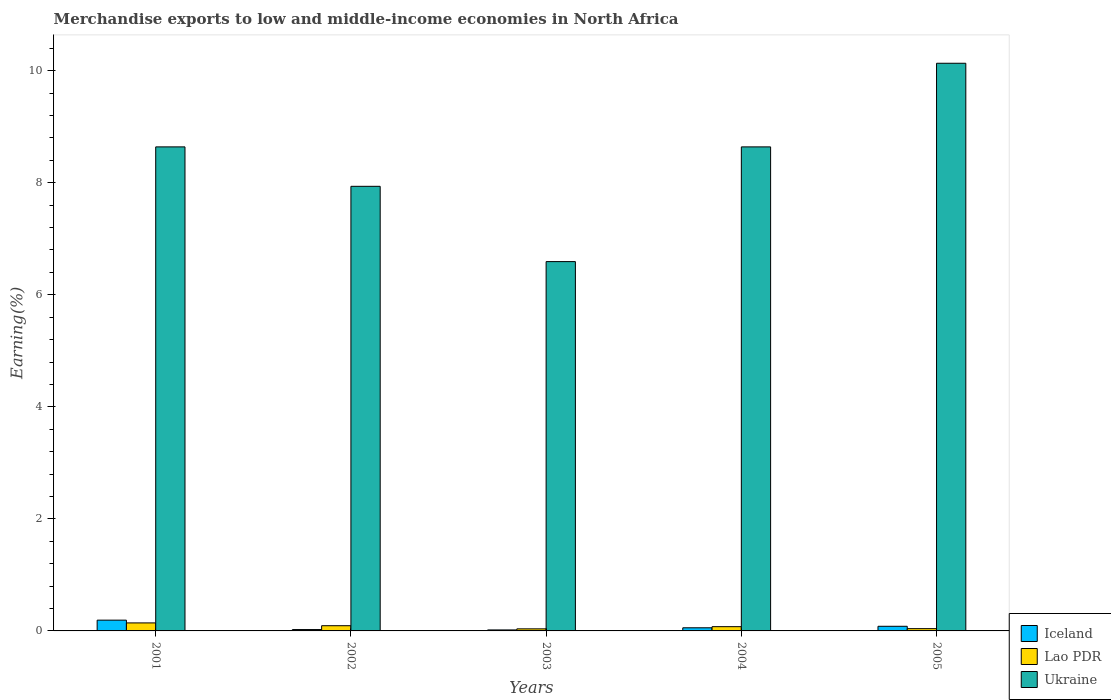How many different coloured bars are there?
Ensure brevity in your answer.  3. How many bars are there on the 3rd tick from the left?
Give a very brief answer. 3. What is the percentage of amount earned from merchandise exports in Lao PDR in 2002?
Give a very brief answer. 0.09. Across all years, what is the maximum percentage of amount earned from merchandise exports in Iceland?
Your response must be concise. 0.19. Across all years, what is the minimum percentage of amount earned from merchandise exports in Lao PDR?
Ensure brevity in your answer.  0.04. In which year was the percentage of amount earned from merchandise exports in Iceland maximum?
Ensure brevity in your answer.  2001. What is the total percentage of amount earned from merchandise exports in Ukraine in the graph?
Ensure brevity in your answer.  41.94. What is the difference between the percentage of amount earned from merchandise exports in Ukraine in 2002 and that in 2005?
Offer a terse response. -2.2. What is the difference between the percentage of amount earned from merchandise exports in Iceland in 2001 and the percentage of amount earned from merchandise exports in Ukraine in 2002?
Offer a terse response. -7.74. What is the average percentage of amount earned from merchandise exports in Ukraine per year?
Offer a very short reply. 8.39. In the year 2005, what is the difference between the percentage of amount earned from merchandise exports in Ukraine and percentage of amount earned from merchandise exports in Lao PDR?
Keep it short and to the point. 10.09. What is the ratio of the percentage of amount earned from merchandise exports in Lao PDR in 2001 to that in 2004?
Your response must be concise. 1.88. What is the difference between the highest and the second highest percentage of amount earned from merchandise exports in Ukraine?
Ensure brevity in your answer.  1.49. What is the difference between the highest and the lowest percentage of amount earned from merchandise exports in Ukraine?
Your response must be concise. 3.54. Is the sum of the percentage of amount earned from merchandise exports in Lao PDR in 2002 and 2004 greater than the maximum percentage of amount earned from merchandise exports in Iceland across all years?
Give a very brief answer. No. What does the 1st bar from the left in 2003 represents?
Provide a succinct answer. Iceland. What does the 2nd bar from the right in 2002 represents?
Offer a terse response. Lao PDR. How many bars are there?
Provide a succinct answer. 15. Are all the bars in the graph horizontal?
Ensure brevity in your answer.  No. Does the graph contain grids?
Offer a very short reply. No. What is the title of the graph?
Keep it short and to the point. Merchandise exports to low and middle-income economies in North Africa. Does "Moldova" appear as one of the legend labels in the graph?
Offer a terse response. No. What is the label or title of the X-axis?
Offer a terse response. Years. What is the label or title of the Y-axis?
Make the answer very short. Earning(%). What is the Earning(%) in Iceland in 2001?
Give a very brief answer. 0.19. What is the Earning(%) in Lao PDR in 2001?
Ensure brevity in your answer.  0.14. What is the Earning(%) in Ukraine in 2001?
Give a very brief answer. 8.64. What is the Earning(%) in Iceland in 2002?
Your response must be concise. 0.02. What is the Earning(%) of Lao PDR in 2002?
Provide a short and direct response. 0.09. What is the Earning(%) of Ukraine in 2002?
Offer a terse response. 7.94. What is the Earning(%) of Iceland in 2003?
Provide a short and direct response. 0.02. What is the Earning(%) of Lao PDR in 2003?
Ensure brevity in your answer.  0.04. What is the Earning(%) of Ukraine in 2003?
Ensure brevity in your answer.  6.59. What is the Earning(%) of Iceland in 2004?
Offer a terse response. 0.06. What is the Earning(%) in Lao PDR in 2004?
Provide a succinct answer. 0.08. What is the Earning(%) in Ukraine in 2004?
Give a very brief answer. 8.64. What is the Earning(%) of Iceland in 2005?
Provide a succinct answer. 0.08. What is the Earning(%) in Lao PDR in 2005?
Your answer should be compact. 0.04. What is the Earning(%) of Ukraine in 2005?
Your answer should be very brief. 10.13. Across all years, what is the maximum Earning(%) of Iceland?
Your answer should be very brief. 0.19. Across all years, what is the maximum Earning(%) in Lao PDR?
Make the answer very short. 0.14. Across all years, what is the maximum Earning(%) in Ukraine?
Offer a terse response. 10.13. Across all years, what is the minimum Earning(%) of Iceland?
Offer a very short reply. 0.02. Across all years, what is the minimum Earning(%) in Lao PDR?
Provide a succinct answer. 0.04. Across all years, what is the minimum Earning(%) of Ukraine?
Give a very brief answer. 6.59. What is the total Earning(%) in Iceland in the graph?
Your answer should be very brief. 0.37. What is the total Earning(%) in Lao PDR in the graph?
Make the answer very short. 0.39. What is the total Earning(%) of Ukraine in the graph?
Give a very brief answer. 41.94. What is the difference between the Earning(%) in Iceland in 2001 and that in 2002?
Your answer should be compact. 0.17. What is the difference between the Earning(%) in Lao PDR in 2001 and that in 2002?
Your answer should be very brief. 0.05. What is the difference between the Earning(%) in Ukraine in 2001 and that in 2002?
Offer a very short reply. 0.7. What is the difference between the Earning(%) of Iceland in 2001 and that in 2003?
Ensure brevity in your answer.  0.17. What is the difference between the Earning(%) of Lao PDR in 2001 and that in 2003?
Offer a terse response. 0.11. What is the difference between the Earning(%) of Ukraine in 2001 and that in 2003?
Make the answer very short. 2.05. What is the difference between the Earning(%) in Iceland in 2001 and that in 2004?
Your answer should be compact. 0.14. What is the difference between the Earning(%) in Lao PDR in 2001 and that in 2004?
Keep it short and to the point. 0.07. What is the difference between the Earning(%) of Iceland in 2001 and that in 2005?
Give a very brief answer. 0.11. What is the difference between the Earning(%) in Lao PDR in 2001 and that in 2005?
Provide a succinct answer. 0.1. What is the difference between the Earning(%) of Ukraine in 2001 and that in 2005?
Keep it short and to the point. -1.49. What is the difference between the Earning(%) in Iceland in 2002 and that in 2003?
Your response must be concise. 0.01. What is the difference between the Earning(%) in Lao PDR in 2002 and that in 2003?
Your response must be concise. 0.06. What is the difference between the Earning(%) in Ukraine in 2002 and that in 2003?
Provide a succinct answer. 1.34. What is the difference between the Earning(%) of Iceland in 2002 and that in 2004?
Keep it short and to the point. -0.03. What is the difference between the Earning(%) in Lao PDR in 2002 and that in 2004?
Give a very brief answer. 0.02. What is the difference between the Earning(%) of Ukraine in 2002 and that in 2004?
Provide a succinct answer. -0.7. What is the difference between the Earning(%) in Iceland in 2002 and that in 2005?
Ensure brevity in your answer.  -0.06. What is the difference between the Earning(%) of Lao PDR in 2002 and that in 2005?
Make the answer very short. 0.05. What is the difference between the Earning(%) in Ukraine in 2002 and that in 2005?
Your answer should be very brief. -2.2. What is the difference between the Earning(%) of Iceland in 2003 and that in 2004?
Provide a short and direct response. -0.04. What is the difference between the Earning(%) of Lao PDR in 2003 and that in 2004?
Offer a very short reply. -0.04. What is the difference between the Earning(%) in Ukraine in 2003 and that in 2004?
Provide a succinct answer. -2.05. What is the difference between the Earning(%) in Iceland in 2003 and that in 2005?
Give a very brief answer. -0.07. What is the difference between the Earning(%) in Lao PDR in 2003 and that in 2005?
Give a very brief answer. -0. What is the difference between the Earning(%) in Ukraine in 2003 and that in 2005?
Your response must be concise. -3.54. What is the difference between the Earning(%) in Iceland in 2004 and that in 2005?
Your response must be concise. -0.03. What is the difference between the Earning(%) of Lao PDR in 2004 and that in 2005?
Your answer should be very brief. 0.04. What is the difference between the Earning(%) in Ukraine in 2004 and that in 2005?
Make the answer very short. -1.49. What is the difference between the Earning(%) in Iceland in 2001 and the Earning(%) in Lao PDR in 2002?
Keep it short and to the point. 0.1. What is the difference between the Earning(%) of Iceland in 2001 and the Earning(%) of Ukraine in 2002?
Provide a succinct answer. -7.74. What is the difference between the Earning(%) of Lao PDR in 2001 and the Earning(%) of Ukraine in 2002?
Ensure brevity in your answer.  -7.79. What is the difference between the Earning(%) of Iceland in 2001 and the Earning(%) of Lao PDR in 2003?
Give a very brief answer. 0.16. What is the difference between the Earning(%) of Lao PDR in 2001 and the Earning(%) of Ukraine in 2003?
Make the answer very short. -6.45. What is the difference between the Earning(%) in Iceland in 2001 and the Earning(%) in Lao PDR in 2004?
Your answer should be very brief. 0.12. What is the difference between the Earning(%) in Iceland in 2001 and the Earning(%) in Ukraine in 2004?
Your response must be concise. -8.45. What is the difference between the Earning(%) in Lao PDR in 2001 and the Earning(%) in Ukraine in 2004?
Your answer should be very brief. -8.5. What is the difference between the Earning(%) in Iceland in 2001 and the Earning(%) in Lao PDR in 2005?
Make the answer very short. 0.15. What is the difference between the Earning(%) of Iceland in 2001 and the Earning(%) of Ukraine in 2005?
Ensure brevity in your answer.  -9.94. What is the difference between the Earning(%) of Lao PDR in 2001 and the Earning(%) of Ukraine in 2005?
Your response must be concise. -9.99. What is the difference between the Earning(%) of Iceland in 2002 and the Earning(%) of Lao PDR in 2003?
Offer a terse response. -0.01. What is the difference between the Earning(%) of Iceland in 2002 and the Earning(%) of Ukraine in 2003?
Provide a short and direct response. -6.57. What is the difference between the Earning(%) of Lao PDR in 2002 and the Earning(%) of Ukraine in 2003?
Your answer should be very brief. -6.5. What is the difference between the Earning(%) in Iceland in 2002 and the Earning(%) in Lao PDR in 2004?
Your response must be concise. -0.05. What is the difference between the Earning(%) in Iceland in 2002 and the Earning(%) in Ukraine in 2004?
Make the answer very short. -8.62. What is the difference between the Earning(%) in Lao PDR in 2002 and the Earning(%) in Ukraine in 2004?
Provide a succinct answer. -8.55. What is the difference between the Earning(%) in Iceland in 2002 and the Earning(%) in Lao PDR in 2005?
Provide a short and direct response. -0.02. What is the difference between the Earning(%) of Iceland in 2002 and the Earning(%) of Ukraine in 2005?
Give a very brief answer. -10.11. What is the difference between the Earning(%) in Lao PDR in 2002 and the Earning(%) in Ukraine in 2005?
Keep it short and to the point. -10.04. What is the difference between the Earning(%) in Iceland in 2003 and the Earning(%) in Lao PDR in 2004?
Provide a short and direct response. -0.06. What is the difference between the Earning(%) of Iceland in 2003 and the Earning(%) of Ukraine in 2004?
Provide a short and direct response. -8.62. What is the difference between the Earning(%) of Lao PDR in 2003 and the Earning(%) of Ukraine in 2004?
Ensure brevity in your answer.  -8.6. What is the difference between the Earning(%) in Iceland in 2003 and the Earning(%) in Lao PDR in 2005?
Your answer should be compact. -0.02. What is the difference between the Earning(%) in Iceland in 2003 and the Earning(%) in Ukraine in 2005?
Your answer should be compact. -10.12. What is the difference between the Earning(%) of Lao PDR in 2003 and the Earning(%) of Ukraine in 2005?
Offer a terse response. -10.1. What is the difference between the Earning(%) in Iceland in 2004 and the Earning(%) in Lao PDR in 2005?
Your answer should be very brief. 0.02. What is the difference between the Earning(%) in Iceland in 2004 and the Earning(%) in Ukraine in 2005?
Ensure brevity in your answer.  -10.08. What is the difference between the Earning(%) in Lao PDR in 2004 and the Earning(%) in Ukraine in 2005?
Provide a short and direct response. -10.06. What is the average Earning(%) of Iceland per year?
Your response must be concise. 0.07. What is the average Earning(%) in Lao PDR per year?
Your answer should be very brief. 0.08. What is the average Earning(%) of Ukraine per year?
Make the answer very short. 8.39. In the year 2001, what is the difference between the Earning(%) of Iceland and Earning(%) of Lao PDR?
Ensure brevity in your answer.  0.05. In the year 2001, what is the difference between the Earning(%) of Iceland and Earning(%) of Ukraine?
Offer a very short reply. -8.45. In the year 2001, what is the difference between the Earning(%) in Lao PDR and Earning(%) in Ukraine?
Make the answer very short. -8.5. In the year 2002, what is the difference between the Earning(%) in Iceland and Earning(%) in Lao PDR?
Make the answer very short. -0.07. In the year 2002, what is the difference between the Earning(%) in Iceland and Earning(%) in Ukraine?
Provide a succinct answer. -7.91. In the year 2002, what is the difference between the Earning(%) in Lao PDR and Earning(%) in Ukraine?
Your answer should be very brief. -7.84. In the year 2003, what is the difference between the Earning(%) of Iceland and Earning(%) of Lao PDR?
Your answer should be very brief. -0.02. In the year 2003, what is the difference between the Earning(%) of Iceland and Earning(%) of Ukraine?
Provide a succinct answer. -6.57. In the year 2003, what is the difference between the Earning(%) in Lao PDR and Earning(%) in Ukraine?
Ensure brevity in your answer.  -6.56. In the year 2004, what is the difference between the Earning(%) in Iceland and Earning(%) in Lao PDR?
Offer a terse response. -0.02. In the year 2004, what is the difference between the Earning(%) in Iceland and Earning(%) in Ukraine?
Give a very brief answer. -8.58. In the year 2004, what is the difference between the Earning(%) in Lao PDR and Earning(%) in Ukraine?
Your answer should be compact. -8.56. In the year 2005, what is the difference between the Earning(%) in Iceland and Earning(%) in Lao PDR?
Your response must be concise. 0.04. In the year 2005, what is the difference between the Earning(%) of Iceland and Earning(%) of Ukraine?
Provide a short and direct response. -10.05. In the year 2005, what is the difference between the Earning(%) of Lao PDR and Earning(%) of Ukraine?
Keep it short and to the point. -10.09. What is the ratio of the Earning(%) of Iceland in 2001 to that in 2002?
Offer a terse response. 7.92. What is the ratio of the Earning(%) of Lao PDR in 2001 to that in 2002?
Keep it short and to the point. 1.54. What is the ratio of the Earning(%) in Ukraine in 2001 to that in 2002?
Your answer should be compact. 1.09. What is the ratio of the Earning(%) of Iceland in 2001 to that in 2003?
Make the answer very short. 10.9. What is the ratio of the Earning(%) of Lao PDR in 2001 to that in 2003?
Your answer should be compact. 3.86. What is the ratio of the Earning(%) of Ukraine in 2001 to that in 2003?
Offer a very short reply. 1.31. What is the ratio of the Earning(%) in Iceland in 2001 to that in 2004?
Provide a succinct answer. 3.44. What is the ratio of the Earning(%) in Lao PDR in 2001 to that in 2004?
Your answer should be compact. 1.88. What is the ratio of the Earning(%) in Ukraine in 2001 to that in 2004?
Offer a very short reply. 1. What is the ratio of the Earning(%) in Iceland in 2001 to that in 2005?
Make the answer very short. 2.32. What is the ratio of the Earning(%) of Lao PDR in 2001 to that in 2005?
Make the answer very short. 3.52. What is the ratio of the Earning(%) in Ukraine in 2001 to that in 2005?
Provide a short and direct response. 0.85. What is the ratio of the Earning(%) of Iceland in 2002 to that in 2003?
Your answer should be very brief. 1.38. What is the ratio of the Earning(%) in Lao PDR in 2002 to that in 2003?
Your answer should be very brief. 2.51. What is the ratio of the Earning(%) of Ukraine in 2002 to that in 2003?
Your answer should be compact. 1.2. What is the ratio of the Earning(%) in Iceland in 2002 to that in 2004?
Keep it short and to the point. 0.43. What is the ratio of the Earning(%) of Lao PDR in 2002 to that in 2004?
Ensure brevity in your answer.  1.23. What is the ratio of the Earning(%) of Ukraine in 2002 to that in 2004?
Give a very brief answer. 0.92. What is the ratio of the Earning(%) in Iceland in 2002 to that in 2005?
Your response must be concise. 0.29. What is the ratio of the Earning(%) in Lao PDR in 2002 to that in 2005?
Offer a very short reply. 2.29. What is the ratio of the Earning(%) of Ukraine in 2002 to that in 2005?
Offer a very short reply. 0.78. What is the ratio of the Earning(%) in Iceland in 2003 to that in 2004?
Make the answer very short. 0.32. What is the ratio of the Earning(%) of Lao PDR in 2003 to that in 2004?
Your answer should be compact. 0.49. What is the ratio of the Earning(%) in Ukraine in 2003 to that in 2004?
Ensure brevity in your answer.  0.76. What is the ratio of the Earning(%) of Iceland in 2003 to that in 2005?
Give a very brief answer. 0.21. What is the ratio of the Earning(%) of Lao PDR in 2003 to that in 2005?
Give a very brief answer. 0.91. What is the ratio of the Earning(%) in Ukraine in 2003 to that in 2005?
Your response must be concise. 0.65. What is the ratio of the Earning(%) in Iceland in 2004 to that in 2005?
Keep it short and to the point. 0.68. What is the ratio of the Earning(%) of Lao PDR in 2004 to that in 2005?
Your answer should be compact. 1.87. What is the ratio of the Earning(%) in Ukraine in 2004 to that in 2005?
Your response must be concise. 0.85. What is the difference between the highest and the second highest Earning(%) in Iceland?
Give a very brief answer. 0.11. What is the difference between the highest and the second highest Earning(%) of Lao PDR?
Give a very brief answer. 0.05. What is the difference between the highest and the second highest Earning(%) in Ukraine?
Provide a short and direct response. 1.49. What is the difference between the highest and the lowest Earning(%) of Iceland?
Keep it short and to the point. 0.17. What is the difference between the highest and the lowest Earning(%) in Lao PDR?
Your answer should be very brief. 0.11. What is the difference between the highest and the lowest Earning(%) of Ukraine?
Provide a succinct answer. 3.54. 